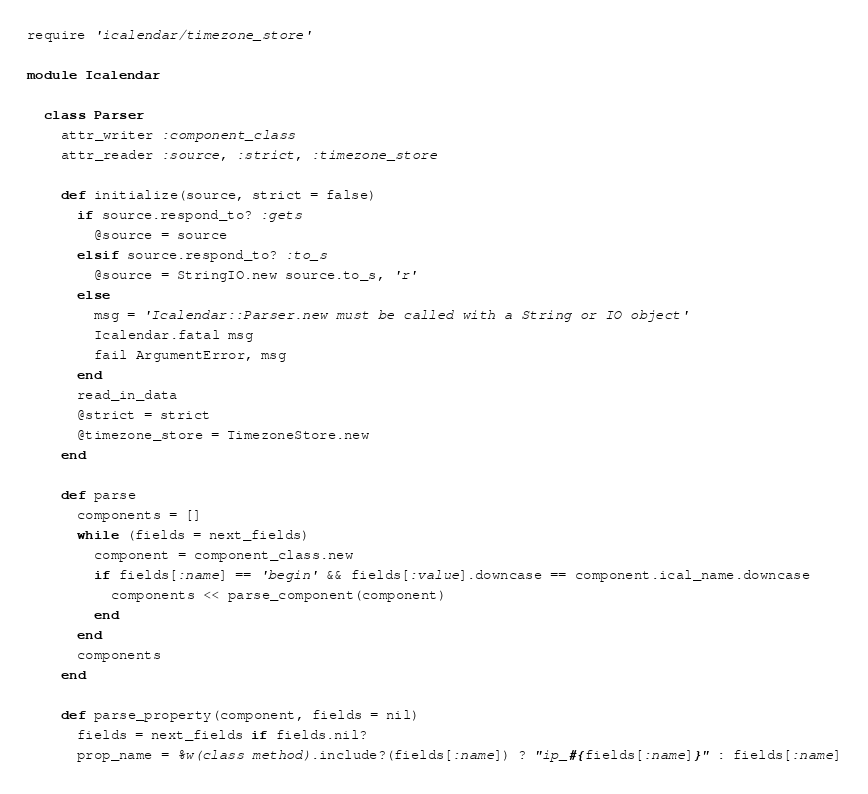Convert code to text. <code><loc_0><loc_0><loc_500><loc_500><_Ruby_>require 'icalendar/timezone_store'

module Icalendar

  class Parser
    attr_writer :component_class
    attr_reader :source, :strict, :timezone_store

    def initialize(source, strict = false)
      if source.respond_to? :gets
        @source = source
      elsif source.respond_to? :to_s
        @source = StringIO.new source.to_s, 'r'
      else
        msg = 'Icalendar::Parser.new must be called with a String or IO object'
        Icalendar.fatal msg
        fail ArgumentError, msg
      end
      read_in_data
      @strict = strict
      @timezone_store = TimezoneStore.new
    end

    def parse
      components = []
      while (fields = next_fields)
        component = component_class.new
        if fields[:name] == 'begin' && fields[:value].downcase == component.ical_name.downcase
          components << parse_component(component)
        end
      end
      components
    end

    def parse_property(component, fields = nil)
      fields = next_fields if fields.nil?
      prop_name = %w(class method).include?(fields[:name]) ? "ip_#{fields[:name]}" : fields[:name]</code> 